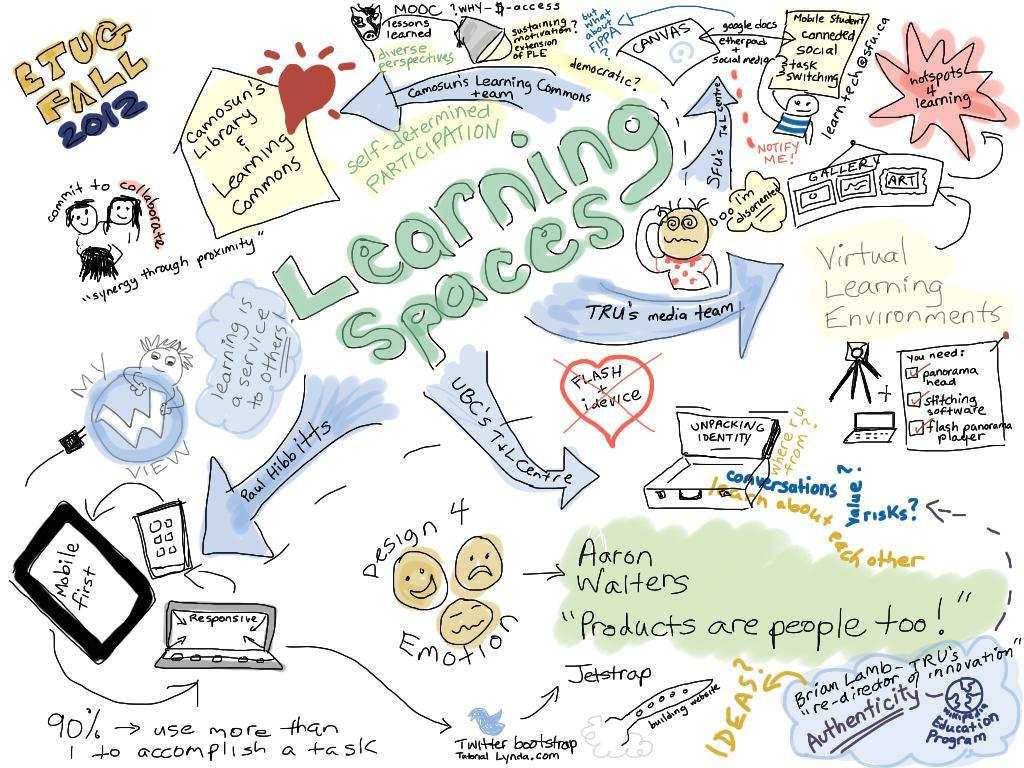What can be observed about the nature of the image? The image is edited. What types of visual elements are present in the image? There are pictures and text in the image. What type of cushion is being used by the coach in the image? There is no coach or cushion present in the image; it only contains pictures and text. 